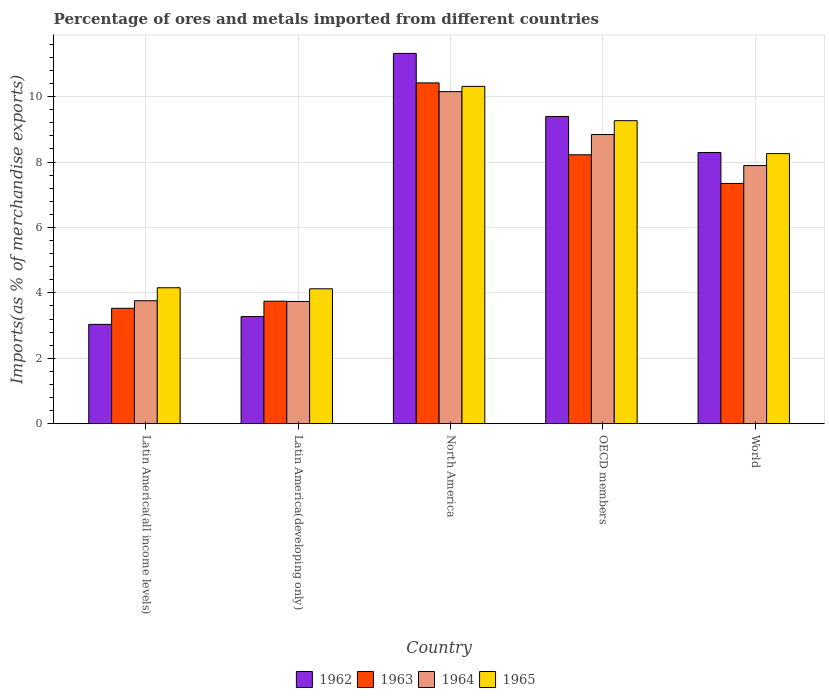How many groups of bars are there?
Give a very brief answer. 5. Are the number of bars on each tick of the X-axis equal?
Offer a terse response. Yes. How many bars are there on the 5th tick from the right?
Your answer should be compact. 4. What is the percentage of imports to different countries in 1963 in OECD members?
Make the answer very short. 8.22. Across all countries, what is the maximum percentage of imports to different countries in 1965?
Provide a short and direct response. 10.31. Across all countries, what is the minimum percentage of imports to different countries in 1962?
Provide a short and direct response. 3.04. In which country was the percentage of imports to different countries in 1962 minimum?
Your answer should be very brief. Latin America(all income levels). What is the total percentage of imports to different countries in 1962 in the graph?
Provide a succinct answer. 35.33. What is the difference between the percentage of imports to different countries in 1962 in Latin America(all income levels) and that in OECD members?
Make the answer very short. -6.36. What is the difference between the percentage of imports to different countries in 1962 in World and the percentage of imports to different countries in 1964 in Latin America(developing only)?
Provide a succinct answer. 4.55. What is the average percentage of imports to different countries in 1965 per country?
Ensure brevity in your answer.  7.22. What is the difference between the percentage of imports to different countries of/in 1964 and percentage of imports to different countries of/in 1963 in OECD members?
Make the answer very short. 0.62. In how many countries, is the percentage of imports to different countries in 1965 greater than 5.6 %?
Make the answer very short. 3. What is the ratio of the percentage of imports to different countries in 1964 in Latin America(all income levels) to that in World?
Your response must be concise. 0.48. What is the difference between the highest and the second highest percentage of imports to different countries in 1965?
Provide a short and direct response. -1.01. What is the difference between the highest and the lowest percentage of imports to different countries in 1963?
Provide a succinct answer. 6.89. In how many countries, is the percentage of imports to different countries in 1962 greater than the average percentage of imports to different countries in 1962 taken over all countries?
Ensure brevity in your answer.  3. What does the 4th bar from the left in Latin America(all income levels) represents?
Make the answer very short. 1965. What does the 2nd bar from the right in OECD members represents?
Your response must be concise. 1964. Is it the case that in every country, the sum of the percentage of imports to different countries in 1964 and percentage of imports to different countries in 1965 is greater than the percentage of imports to different countries in 1962?
Your answer should be compact. Yes. How many bars are there?
Ensure brevity in your answer.  20. Are all the bars in the graph horizontal?
Give a very brief answer. No. How many countries are there in the graph?
Keep it short and to the point. 5. Are the values on the major ticks of Y-axis written in scientific E-notation?
Your answer should be very brief. No. How are the legend labels stacked?
Your answer should be compact. Horizontal. What is the title of the graph?
Offer a very short reply. Percentage of ores and metals imported from different countries. What is the label or title of the Y-axis?
Offer a very short reply. Imports(as % of merchandise exports). What is the Imports(as % of merchandise exports) in 1962 in Latin America(all income levels)?
Provide a succinct answer. 3.04. What is the Imports(as % of merchandise exports) in 1963 in Latin America(all income levels)?
Offer a very short reply. 3.53. What is the Imports(as % of merchandise exports) in 1964 in Latin America(all income levels)?
Give a very brief answer. 3.76. What is the Imports(as % of merchandise exports) in 1965 in Latin America(all income levels)?
Your answer should be compact. 4.16. What is the Imports(as % of merchandise exports) in 1962 in Latin America(developing only)?
Offer a terse response. 3.28. What is the Imports(as % of merchandise exports) of 1963 in Latin America(developing only)?
Offer a terse response. 3.75. What is the Imports(as % of merchandise exports) of 1964 in Latin America(developing only)?
Keep it short and to the point. 3.74. What is the Imports(as % of merchandise exports) of 1965 in Latin America(developing only)?
Ensure brevity in your answer.  4.13. What is the Imports(as % of merchandise exports) of 1962 in North America?
Offer a very short reply. 11.32. What is the Imports(as % of merchandise exports) of 1963 in North America?
Your answer should be very brief. 10.42. What is the Imports(as % of merchandise exports) in 1964 in North America?
Keep it short and to the point. 10.15. What is the Imports(as % of merchandise exports) in 1965 in North America?
Offer a terse response. 10.31. What is the Imports(as % of merchandise exports) of 1962 in OECD members?
Make the answer very short. 9.39. What is the Imports(as % of merchandise exports) in 1963 in OECD members?
Keep it short and to the point. 8.22. What is the Imports(as % of merchandise exports) in 1964 in OECD members?
Provide a succinct answer. 8.84. What is the Imports(as % of merchandise exports) of 1965 in OECD members?
Provide a succinct answer. 9.27. What is the Imports(as % of merchandise exports) in 1962 in World?
Offer a very short reply. 8.29. What is the Imports(as % of merchandise exports) of 1963 in World?
Your answer should be very brief. 7.35. What is the Imports(as % of merchandise exports) in 1964 in World?
Offer a terse response. 7.89. What is the Imports(as % of merchandise exports) in 1965 in World?
Your answer should be compact. 8.26. Across all countries, what is the maximum Imports(as % of merchandise exports) of 1962?
Keep it short and to the point. 11.32. Across all countries, what is the maximum Imports(as % of merchandise exports) in 1963?
Give a very brief answer. 10.42. Across all countries, what is the maximum Imports(as % of merchandise exports) in 1964?
Offer a terse response. 10.15. Across all countries, what is the maximum Imports(as % of merchandise exports) of 1965?
Your answer should be compact. 10.31. Across all countries, what is the minimum Imports(as % of merchandise exports) in 1962?
Ensure brevity in your answer.  3.04. Across all countries, what is the minimum Imports(as % of merchandise exports) of 1963?
Offer a very short reply. 3.53. Across all countries, what is the minimum Imports(as % of merchandise exports) of 1964?
Provide a short and direct response. 3.74. Across all countries, what is the minimum Imports(as % of merchandise exports) in 1965?
Provide a succinct answer. 4.13. What is the total Imports(as % of merchandise exports) of 1962 in the graph?
Provide a short and direct response. 35.33. What is the total Imports(as % of merchandise exports) in 1963 in the graph?
Provide a short and direct response. 33.27. What is the total Imports(as % of merchandise exports) in 1964 in the graph?
Make the answer very short. 34.39. What is the total Imports(as % of merchandise exports) of 1965 in the graph?
Your answer should be compact. 36.12. What is the difference between the Imports(as % of merchandise exports) of 1962 in Latin America(all income levels) and that in Latin America(developing only)?
Your answer should be very brief. -0.24. What is the difference between the Imports(as % of merchandise exports) of 1963 in Latin America(all income levels) and that in Latin America(developing only)?
Keep it short and to the point. -0.22. What is the difference between the Imports(as % of merchandise exports) of 1964 in Latin America(all income levels) and that in Latin America(developing only)?
Your answer should be compact. 0.02. What is the difference between the Imports(as % of merchandise exports) of 1965 in Latin America(all income levels) and that in Latin America(developing only)?
Keep it short and to the point. 0.03. What is the difference between the Imports(as % of merchandise exports) of 1962 in Latin America(all income levels) and that in North America?
Your answer should be compact. -8.28. What is the difference between the Imports(as % of merchandise exports) in 1963 in Latin America(all income levels) and that in North America?
Keep it short and to the point. -6.89. What is the difference between the Imports(as % of merchandise exports) of 1964 in Latin America(all income levels) and that in North America?
Ensure brevity in your answer.  -6.39. What is the difference between the Imports(as % of merchandise exports) in 1965 in Latin America(all income levels) and that in North America?
Provide a short and direct response. -6.16. What is the difference between the Imports(as % of merchandise exports) in 1962 in Latin America(all income levels) and that in OECD members?
Your answer should be very brief. -6.36. What is the difference between the Imports(as % of merchandise exports) in 1963 in Latin America(all income levels) and that in OECD members?
Provide a short and direct response. -4.69. What is the difference between the Imports(as % of merchandise exports) in 1964 in Latin America(all income levels) and that in OECD members?
Your answer should be very brief. -5.08. What is the difference between the Imports(as % of merchandise exports) of 1965 in Latin America(all income levels) and that in OECD members?
Ensure brevity in your answer.  -5.11. What is the difference between the Imports(as % of merchandise exports) in 1962 in Latin America(all income levels) and that in World?
Provide a succinct answer. -5.25. What is the difference between the Imports(as % of merchandise exports) of 1963 in Latin America(all income levels) and that in World?
Your answer should be compact. -3.82. What is the difference between the Imports(as % of merchandise exports) in 1964 in Latin America(all income levels) and that in World?
Your response must be concise. -4.13. What is the difference between the Imports(as % of merchandise exports) in 1965 in Latin America(all income levels) and that in World?
Provide a succinct answer. -4.1. What is the difference between the Imports(as % of merchandise exports) of 1962 in Latin America(developing only) and that in North America?
Make the answer very short. -8.05. What is the difference between the Imports(as % of merchandise exports) of 1963 in Latin America(developing only) and that in North America?
Ensure brevity in your answer.  -6.67. What is the difference between the Imports(as % of merchandise exports) in 1964 in Latin America(developing only) and that in North America?
Provide a short and direct response. -6.41. What is the difference between the Imports(as % of merchandise exports) in 1965 in Latin America(developing only) and that in North America?
Your response must be concise. -6.19. What is the difference between the Imports(as % of merchandise exports) of 1962 in Latin America(developing only) and that in OECD members?
Keep it short and to the point. -6.12. What is the difference between the Imports(as % of merchandise exports) in 1963 in Latin America(developing only) and that in OECD members?
Your answer should be compact. -4.48. What is the difference between the Imports(as % of merchandise exports) of 1964 in Latin America(developing only) and that in OECD members?
Provide a short and direct response. -5.1. What is the difference between the Imports(as % of merchandise exports) of 1965 in Latin America(developing only) and that in OECD members?
Make the answer very short. -5.14. What is the difference between the Imports(as % of merchandise exports) of 1962 in Latin America(developing only) and that in World?
Give a very brief answer. -5.02. What is the difference between the Imports(as % of merchandise exports) in 1963 in Latin America(developing only) and that in World?
Offer a terse response. -3.6. What is the difference between the Imports(as % of merchandise exports) in 1964 in Latin America(developing only) and that in World?
Offer a terse response. -4.15. What is the difference between the Imports(as % of merchandise exports) in 1965 in Latin America(developing only) and that in World?
Offer a terse response. -4.13. What is the difference between the Imports(as % of merchandise exports) of 1962 in North America and that in OECD members?
Provide a short and direct response. 1.93. What is the difference between the Imports(as % of merchandise exports) in 1963 in North America and that in OECD members?
Keep it short and to the point. 2.2. What is the difference between the Imports(as % of merchandise exports) in 1964 in North America and that in OECD members?
Offer a very short reply. 1.31. What is the difference between the Imports(as % of merchandise exports) of 1965 in North America and that in OECD members?
Offer a very short reply. 1.05. What is the difference between the Imports(as % of merchandise exports) of 1962 in North America and that in World?
Your response must be concise. 3.03. What is the difference between the Imports(as % of merchandise exports) of 1963 in North America and that in World?
Keep it short and to the point. 3.07. What is the difference between the Imports(as % of merchandise exports) in 1964 in North America and that in World?
Your answer should be very brief. 2.26. What is the difference between the Imports(as % of merchandise exports) in 1965 in North America and that in World?
Provide a succinct answer. 2.06. What is the difference between the Imports(as % of merchandise exports) in 1962 in OECD members and that in World?
Provide a succinct answer. 1.1. What is the difference between the Imports(as % of merchandise exports) in 1963 in OECD members and that in World?
Your response must be concise. 0.88. What is the difference between the Imports(as % of merchandise exports) in 1964 in OECD members and that in World?
Offer a very short reply. 0.95. What is the difference between the Imports(as % of merchandise exports) of 1965 in OECD members and that in World?
Your response must be concise. 1.01. What is the difference between the Imports(as % of merchandise exports) in 1962 in Latin America(all income levels) and the Imports(as % of merchandise exports) in 1963 in Latin America(developing only)?
Provide a short and direct response. -0.71. What is the difference between the Imports(as % of merchandise exports) of 1962 in Latin America(all income levels) and the Imports(as % of merchandise exports) of 1964 in Latin America(developing only)?
Offer a terse response. -0.7. What is the difference between the Imports(as % of merchandise exports) in 1962 in Latin America(all income levels) and the Imports(as % of merchandise exports) in 1965 in Latin America(developing only)?
Offer a very short reply. -1.09. What is the difference between the Imports(as % of merchandise exports) in 1963 in Latin America(all income levels) and the Imports(as % of merchandise exports) in 1964 in Latin America(developing only)?
Your answer should be very brief. -0.21. What is the difference between the Imports(as % of merchandise exports) in 1963 in Latin America(all income levels) and the Imports(as % of merchandise exports) in 1965 in Latin America(developing only)?
Your response must be concise. -0.6. What is the difference between the Imports(as % of merchandise exports) of 1964 in Latin America(all income levels) and the Imports(as % of merchandise exports) of 1965 in Latin America(developing only)?
Provide a succinct answer. -0.36. What is the difference between the Imports(as % of merchandise exports) in 1962 in Latin America(all income levels) and the Imports(as % of merchandise exports) in 1963 in North America?
Your response must be concise. -7.38. What is the difference between the Imports(as % of merchandise exports) in 1962 in Latin America(all income levels) and the Imports(as % of merchandise exports) in 1964 in North America?
Provide a succinct answer. -7.11. What is the difference between the Imports(as % of merchandise exports) in 1962 in Latin America(all income levels) and the Imports(as % of merchandise exports) in 1965 in North America?
Your answer should be very brief. -7.28. What is the difference between the Imports(as % of merchandise exports) in 1963 in Latin America(all income levels) and the Imports(as % of merchandise exports) in 1964 in North America?
Keep it short and to the point. -6.62. What is the difference between the Imports(as % of merchandise exports) of 1963 in Latin America(all income levels) and the Imports(as % of merchandise exports) of 1965 in North America?
Your answer should be very brief. -6.79. What is the difference between the Imports(as % of merchandise exports) of 1964 in Latin America(all income levels) and the Imports(as % of merchandise exports) of 1965 in North America?
Ensure brevity in your answer.  -6.55. What is the difference between the Imports(as % of merchandise exports) in 1962 in Latin America(all income levels) and the Imports(as % of merchandise exports) in 1963 in OECD members?
Make the answer very short. -5.18. What is the difference between the Imports(as % of merchandise exports) of 1962 in Latin America(all income levels) and the Imports(as % of merchandise exports) of 1964 in OECD members?
Provide a succinct answer. -5.8. What is the difference between the Imports(as % of merchandise exports) of 1962 in Latin America(all income levels) and the Imports(as % of merchandise exports) of 1965 in OECD members?
Your response must be concise. -6.23. What is the difference between the Imports(as % of merchandise exports) of 1963 in Latin America(all income levels) and the Imports(as % of merchandise exports) of 1964 in OECD members?
Provide a succinct answer. -5.31. What is the difference between the Imports(as % of merchandise exports) of 1963 in Latin America(all income levels) and the Imports(as % of merchandise exports) of 1965 in OECD members?
Ensure brevity in your answer.  -5.74. What is the difference between the Imports(as % of merchandise exports) of 1964 in Latin America(all income levels) and the Imports(as % of merchandise exports) of 1965 in OECD members?
Offer a terse response. -5.5. What is the difference between the Imports(as % of merchandise exports) in 1962 in Latin America(all income levels) and the Imports(as % of merchandise exports) in 1963 in World?
Your answer should be compact. -4.31. What is the difference between the Imports(as % of merchandise exports) of 1962 in Latin America(all income levels) and the Imports(as % of merchandise exports) of 1964 in World?
Offer a very short reply. -4.85. What is the difference between the Imports(as % of merchandise exports) of 1962 in Latin America(all income levels) and the Imports(as % of merchandise exports) of 1965 in World?
Provide a short and direct response. -5.22. What is the difference between the Imports(as % of merchandise exports) of 1963 in Latin America(all income levels) and the Imports(as % of merchandise exports) of 1964 in World?
Give a very brief answer. -4.36. What is the difference between the Imports(as % of merchandise exports) of 1963 in Latin America(all income levels) and the Imports(as % of merchandise exports) of 1965 in World?
Your response must be concise. -4.73. What is the difference between the Imports(as % of merchandise exports) of 1964 in Latin America(all income levels) and the Imports(as % of merchandise exports) of 1965 in World?
Your answer should be compact. -4.5. What is the difference between the Imports(as % of merchandise exports) in 1962 in Latin America(developing only) and the Imports(as % of merchandise exports) in 1963 in North America?
Provide a short and direct response. -7.14. What is the difference between the Imports(as % of merchandise exports) of 1962 in Latin America(developing only) and the Imports(as % of merchandise exports) of 1964 in North America?
Your response must be concise. -6.88. What is the difference between the Imports(as % of merchandise exports) in 1962 in Latin America(developing only) and the Imports(as % of merchandise exports) in 1965 in North America?
Offer a very short reply. -7.04. What is the difference between the Imports(as % of merchandise exports) of 1963 in Latin America(developing only) and the Imports(as % of merchandise exports) of 1964 in North America?
Your response must be concise. -6.41. What is the difference between the Imports(as % of merchandise exports) in 1963 in Latin America(developing only) and the Imports(as % of merchandise exports) in 1965 in North America?
Ensure brevity in your answer.  -6.57. What is the difference between the Imports(as % of merchandise exports) in 1964 in Latin America(developing only) and the Imports(as % of merchandise exports) in 1965 in North America?
Offer a very short reply. -6.58. What is the difference between the Imports(as % of merchandise exports) of 1962 in Latin America(developing only) and the Imports(as % of merchandise exports) of 1963 in OECD members?
Offer a very short reply. -4.95. What is the difference between the Imports(as % of merchandise exports) of 1962 in Latin America(developing only) and the Imports(as % of merchandise exports) of 1964 in OECD members?
Make the answer very short. -5.57. What is the difference between the Imports(as % of merchandise exports) in 1962 in Latin America(developing only) and the Imports(as % of merchandise exports) in 1965 in OECD members?
Offer a very short reply. -5.99. What is the difference between the Imports(as % of merchandise exports) of 1963 in Latin America(developing only) and the Imports(as % of merchandise exports) of 1964 in OECD members?
Provide a succinct answer. -5.1. What is the difference between the Imports(as % of merchandise exports) in 1963 in Latin America(developing only) and the Imports(as % of merchandise exports) in 1965 in OECD members?
Provide a short and direct response. -5.52. What is the difference between the Imports(as % of merchandise exports) of 1964 in Latin America(developing only) and the Imports(as % of merchandise exports) of 1965 in OECD members?
Ensure brevity in your answer.  -5.53. What is the difference between the Imports(as % of merchandise exports) of 1962 in Latin America(developing only) and the Imports(as % of merchandise exports) of 1963 in World?
Give a very brief answer. -4.07. What is the difference between the Imports(as % of merchandise exports) in 1962 in Latin America(developing only) and the Imports(as % of merchandise exports) in 1964 in World?
Provide a succinct answer. -4.62. What is the difference between the Imports(as % of merchandise exports) in 1962 in Latin America(developing only) and the Imports(as % of merchandise exports) in 1965 in World?
Keep it short and to the point. -4.98. What is the difference between the Imports(as % of merchandise exports) in 1963 in Latin America(developing only) and the Imports(as % of merchandise exports) in 1964 in World?
Your answer should be compact. -4.15. What is the difference between the Imports(as % of merchandise exports) in 1963 in Latin America(developing only) and the Imports(as % of merchandise exports) in 1965 in World?
Your answer should be very brief. -4.51. What is the difference between the Imports(as % of merchandise exports) of 1964 in Latin America(developing only) and the Imports(as % of merchandise exports) of 1965 in World?
Offer a very short reply. -4.52. What is the difference between the Imports(as % of merchandise exports) in 1962 in North America and the Imports(as % of merchandise exports) in 1964 in OECD members?
Your answer should be compact. 2.48. What is the difference between the Imports(as % of merchandise exports) of 1962 in North America and the Imports(as % of merchandise exports) of 1965 in OECD members?
Provide a succinct answer. 2.06. What is the difference between the Imports(as % of merchandise exports) in 1963 in North America and the Imports(as % of merchandise exports) in 1964 in OECD members?
Make the answer very short. 1.58. What is the difference between the Imports(as % of merchandise exports) of 1963 in North America and the Imports(as % of merchandise exports) of 1965 in OECD members?
Offer a terse response. 1.16. What is the difference between the Imports(as % of merchandise exports) in 1964 in North America and the Imports(as % of merchandise exports) in 1965 in OECD members?
Make the answer very short. 0.89. What is the difference between the Imports(as % of merchandise exports) in 1962 in North America and the Imports(as % of merchandise exports) in 1963 in World?
Provide a short and direct response. 3.98. What is the difference between the Imports(as % of merchandise exports) of 1962 in North America and the Imports(as % of merchandise exports) of 1964 in World?
Ensure brevity in your answer.  3.43. What is the difference between the Imports(as % of merchandise exports) in 1962 in North America and the Imports(as % of merchandise exports) in 1965 in World?
Make the answer very short. 3.06. What is the difference between the Imports(as % of merchandise exports) in 1963 in North America and the Imports(as % of merchandise exports) in 1964 in World?
Your response must be concise. 2.53. What is the difference between the Imports(as % of merchandise exports) in 1963 in North America and the Imports(as % of merchandise exports) in 1965 in World?
Make the answer very short. 2.16. What is the difference between the Imports(as % of merchandise exports) of 1964 in North America and the Imports(as % of merchandise exports) of 1965 in World?
Give a very brief answer. 1.89. What is the difference between the Imports(as % of merchandise exports) in 1962 in OECD members and the Imports(as % of merchandise exports) in 1963 in World?
Give a very brief answer. 2.05. What is the difference between the Imports(as % of merchandise exports) in 1962 in OECD members and the Imports(as % of merchandise exports) in 1964 in World?
Provide a succinct answer. 1.5. What is the difference between the Imports(as % of merchandise exports) in 1962 in OECD members and the Imports(as % of merchandise exports) in 1965 in World?
Provide a succinct answer. 1.13. What is the difference between the Imports(as % of merchandise exports) of 1963 in OECD members and the Imports(as % of merchandise exports) of 1964 in World?
Provide a succinct answer. 0.33. What is the difference between the Imports(as % of merchandise exports) of 1963 in OECD members and the Imports(as % of merchandise exports) of 1965 in World?
Ensure brevity in your answer.  -0.04. What is the difference between the Imports(as % of merchandise exports) in 1964 in OECD members and the Imports(as % of merchandise exports) in 1965 in World?
Offer a terse response. 0.58. What is the average Imports(as % of merchandise exports) in 1962 per country?
Give a very brief answer. 7.07. What is the average Imports(as % of merchandise exports) in 1963 per country?
Keep it short and to the point. 6.65. What is the average Imports(as % of merchandise exports) in 1964 per country?
Give a very brief answer. 6.88. What is the average Imports(as % of merchandise exports) in 1965 per country?
Your answer should be compact. 7.22. What is the difference between the Imports(as % of merchandise exports) of 1962 and Imports(as % of merchandise exports) of 1963 in Latin America(all income levels)?
Offer a very short reply. -0.49. What is the difference between the Imports(as % of merchandise exports) of 1962 and Imports(as % of merchandise exports) of 1964 in Latin America(all income levels)?
Offer a very short reply. -0.72. What is the difference between the Imports(as % of merchandise exports) in 1962 and Imports(as % of merchandise exports) in 1965 in Latin America(all income levels)?
Offer a very short reply. -1.12. What is the difference between the Imports(as % of merchandise exports) of 1963 and Imports(as % of merchandise exports) of 1964 in Latin America(all income levels)?
Your response must be concise. -0.23. What is the difference between the Imports(as % of merchandise exports) in 1963 and Imports(as % of merchandise exports) in 1965 in Latin America(all income levels)?
Offer a terse response. -0.63. What is the difference between the Imports(as % of merchandise exports) of 1964 and Imports(as % of merchandise exports) of 1965 in Latin America(all income levels)?
Make the answer very short. -0.4. What is the difference between the Imports(as % of merchandise exports) of 1962 and Imports(as % of merchandise exports) of 1963 in Latin America(developing only)?
Keep it short and to the point. -0.47. What is the difference between the Imports(as % of merchandise exports) of 1962 and Imports(as % of merchandise exports) of 1964 in Latin America(developing only)?
Your answer should be compact. -0.46. What is the difference between the Imports(as % of merchandise exports) of 1962 and Imports(as % of merchandise exports) of 1965 in Latin America(developing only)?
Provide a succinct answer. -0.85. What is the difference between the Imports(as % of merchandise exports) in 1963 and Imports(as % of merchandise exports) in 1964 in Latin America(developing only)?
Ensure brevity in your answer.  0.01. What is the difference between the Imports(as % of merchandise exports) of 1963 and Imports(as % of merchandise exports) of 1965 in Latin America(developing only)?
Your response must be concise. -0.38. What is the difference between the Imports(as % of merchandise exports) in 1964 and Imports(as % of merchandise exports) in 1965 in Latin America(developing only)?
Your answer should be very brief. -0.39. What is the difference between the Imports(as % of merchandise exports) in 1962 and Imports(as % of merchandise exports) in 1963 in North America?
Your answer should be compact. 0.9. What is the difference between the Imports(as % of merchandise exports) of 1962 and Imports(as % of merchandise exports) of 1964 in North America?
Keep it short and to the point. 1.17. What is the difference between the Imports(as % of merchandise exports) in 1962 and Imports(as % of merchandise exports) in 1965 in North America?
Give a very brief answer. 1.01. What is the difference between the Imports(as % of merchandise exports) of 1963 and Imports(as % of merchandise exports) of 1964 in North America?
Offer a very short reply. 0.27. What is the difference between the Imports(as % of merchandise exports) in 1963 and Imports(as % of merchandise exports) in 1965 in North America?
Give a very brief answer. 0.11. What is the difference between the Imports(as % of merchandise exports) of 1964 and Imports(as % of merchandise exports) of 1965 in North America?
Give a very brief answer. -0.16. What is the difference between the Imports(as % of merchandise exports) of 1962 and Imports(as % of merchandise exports) of 1963 in OECD members?
Your answer should be compact. 1.17. What is the difference between the Imports(as % of merchandise exports) in 1962 and Imports(as % of merchandise exports) in 1964 in OECD members?
Give a very brief answer. 0.55. What is the difference between the Imports(as % of merchandise exports) in 1962 and Imports(as % of merchandise exports) in 1965 in OECD members?
Provide a short and direct response. 0.13. What is the difference between the Imports(as % of merchandise exports) in 1963 and Imports(as % of merchandise exports) in 1964 in OECD members?
Make the answer very short. -0.62. What is the difference between the Imports(as % of merchandise exports) of 1963 and Imports(as % of merchandise exports) of 1965 in OECD members?
Your answer should be very brief. -1.04. What is the difference between the Imports(as % of merchandise exports) in 1964 and Imports(as % of merchandise exports) in 1965 in OECD members?
Offer a very short reply. -0.42. What is the difference between the Imports(as % of merchandise exports) in 1962 and Imports(as % of merchandise exports) in 1963 in World?
Your answer should be very brief. 0.95. What is the difference between the Imports(as % of merchandise exports) in 1962 and Imports(as % of merchandise exports) in 1964 in World?
Give a very brief answer. 0.4. What is the difference between the Imports(as % of merchandise exports) in 1962 and Imports(as % of merchandise exports) in 1965 in World?
Offer a terse response. 0.03. What is the difference between the Imports(as % of merchandise exports) in 1963 and Imports(as % of merchandise exports) in 1964 in World?
Your response must be concise. -0.55. What is the difference between the Imports(as % of merchandise exports) of 1963 and Imports(as % of merchandise exports) of 1965 in World?
Provide a succinct answer. -0.91. What is the difference between the Imports(as % of merchandise exports) in 1964 and Imports(as % of merchandise exports) in 1965 in World?
Your answer should be compact. -0.37. What is the ratio of the Imports(as % of merchandise exports) in 1962 in Latin America(all income levels) to that in Latin America(developing only)?
Offer a very short reply. 0.93. What is the ratio of the Imports(as % of merchandise exports) in 1963 in Latin America(all income levels) to that in Latin America(developing only)?
Offer a terse response. 0.94. What is the ratio of the Imports(as % of merchandise exports) of 1965 in Latin America(all income levels) to that in Latin America(developing only)?
Make the answer very short. 1.01. What is the ratio of the Imports(as % of merchandise exports) in 1962 in Latin America(all income levels) to that in North America?
Make the answer very short. 0.27. What is the ratio of the Imports(as % of merchandise exports) of 1963 in Latin America(all income levels) to that in North America?
Provide a short and direct response. 0.34. What is the ratio of the Imports(as % of merchandise exports) of 1964 in Latin America(all income levels) to that in North America?
Give a very brief answer. 0.37. What is the ratio of the Imports(as % of merchandise exports) of 1965 in Latin America(all income levels) to that in North America?
Keep it short and to the point. 0.4. What is the ratio of the Imports(as % of merchandise exports) in 1962 in Latin America(all income levels) to that in OECD members?
Keep it short and to the point. 0.32. What is the ratio of the Imports(as % of merchandise exports) in 1963 in Latin America(all income levels) to that in OECD members?
Ensure brevity in your answer.  0.43. What is the ratio of the Imports(as % of merchandise exports) of 1964 in Latin America(all income levels) to that in OECD members?
Your answer should be very brief. 0.43. What is the ratio of the Imports(as % of merchandise exports) of 1965 in Latin America(all income levels) to that in OECD members?
Your answer should be compact. 0.45. What is the ratio of the Imports(as % of merchandise exports) of 1962 in Latin America(all income levels) to that in World?
Keep it short and to the point. 0.37. What is the ratio of the Imports(as % of merchandise exports) of 1963 in Latin America(all income levels) to that in World?
Your answer should be compact. 0.48. What is the ratio of the Imports(as % of merchandise exports) in 1964 in Latin America(all income levels) to that in World?
Your answer should be compact. 0.48. What is the ratio of the Imports(as % of merchandise exports) in 1965 in Latin America(all income levels) to that in World?
Offer a terse response. 0.5. What is the ratio of the Imports(as % of merchandise exports) in 1962 in Latin America(developing only) to that in North America?
Ensure brevity in your answer.  0.29. What is the ratio of the Imports(as % of merchandise exports) of 1963 in Latin America(developing only) to that in North America?
Your answer should be very brief. 0.36. What is the ratio of the Imports(as % of merchandise exports) in 1964 in Latin America(developing only) to that in North America?
Make the answer very short. 0.37. What is the ratio of the Imports(as % of merchandise exports) in 1965 in Latin America(developing only) to that in North America?
Make the answer very short. 0.4. What is the ratio of the Imports(as % of merchandise exports) of 1962 in Latin America(developing only) to that in OECD members?
Provide a succinct answer. 0.35. What is the ratio of the Imports(as % of merchandise exports) in 1963 in Latin America(developing only) to that in OECD members?
Provide a short and direct response. 0.46. What is the ratio of the Imports(as % of merchandise exports) of 1964 in Latin America(developing only) to that in OECD members?
Offer a terse response. 0.42. What is the ratio of the Imports(as % of merchandise exports) in 1965 in Latin America(developing only) to that in OECD members?
Your answer should be very brief. 0.45. What is the ratio of the Imports(as % of merchandise exports) in 1962 in Latin America(developing only) to that in World?
Your answer should be compact. 0.4. What is the ratio of the Imports(as % of merchandise exports) in 1963 in Latin America(developing only) to that in World?
Offer a very short reply. 0.51. What is the ratio of the Imports(as % of merchandise exports) of 1964 in Latin America(developing only) to that in World?
Your response must be concise. 0.47. What is the ratio of the Imports(as % of merchandise exports) in 1965 in Latin America(developing only) to that in World?
Provide a succinct answer. 0.5. What is the ratio of the Imports(as % of merchandise exports) in 1962 in North America to that in OECD members?
Your response must be concise. 1.21. What is the ratio of the Imports(as % of merchandise exports) in 1963 in North America to that in OECD members?
Your answer should be very brief. 1.27. What is the ratio of the Imports(as % of merchandise exports) of 1964 in North America to that in OECD members?
Your answer should be very brief. 1.15. What is the ratio of the Imports(as % of merchandise exports) of 1965 in North America to that in OECD members?
Your answer should be very brief. 1.11. What is the ratio of the Imports(as % of merchandise exports) of 1962 in North America to that in World?
Ensure brevity in your answer.  1.37. What is the ratio of the Imports(as % of merchandise exports) in 1963 in North America to that in World?
Offer a very short reply. 1.42. What is the ratio of the Imports(as % of merchandise exports) of 1964 in North America to that in World?
Your answer should be very brief. 1.29. What is the ratio of the Imports(as % of merchandise exports) of 1965 in North America to that in World?
Ensure brevity in your answer.  1.25. What is the ratio of the Imports(as % of merchandise exports) in 1962 in OECD members to that in World?
Your answer should be very brief. 1.13. What is the ratio of the Imports(as % of merchandise exports) of 1963 in OECD members to that in World?
Make the answer very short. 1.12. What is the ratio of the Imports(as % of merchandise exports) in 1964 in OECD members to that in World?
Keep it short and to the point. 1.12. What is the ratio of the Imports(as % of merchandise exports) in 1965 in OECD members to that in World?
Your response must be concise. 1.12. What is the difference between the highest and the second highest Imports(as % of merchandise exports) of 1962?
Your response must be concise. 1.93. What is the difference between the highest and the second highest Imports(as % of merchandise exports) of 1963?
Provide a succinct answer. 2.2. What is the difference between the highest and the second highest Imports(as % of merchandise exports) in 1964?
Keep it short and to the point. 1.31. What is the difference between the highest and the second highest Imports(as % of merchandise exports) in 1965?
Provide a succinct answer. 1.05. What is the difference between the highest and the lowest Imports(as % of merchandise exports) in 1962?
Your answer should be compact. 8.28. What is the difference between the highest and the lowest Imports(as % of merchandise exports) of 1963?
Provide a short and direct response. 6.89. What is the difference between the highest and the lowest Imports(as % of merchandise exports) in 1964?
Offer a terse response. 6.41. What is the difference between the highest and the lowest Imports(as % of merchandise exports) of 1965?
Offer a very short reply. 6.19. 